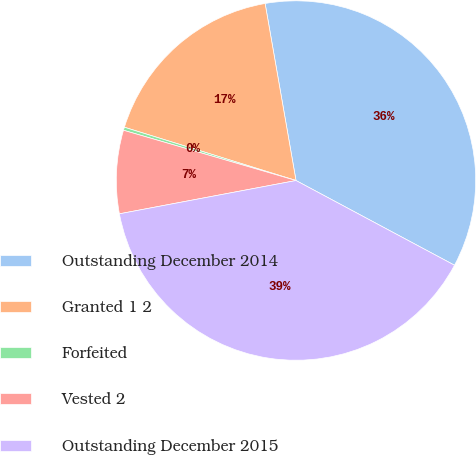Convert chart to OTSL. <chart><loc_0><loc_0><loc_500><loc_500><pie_chart><fcel>Outstanding December 2014<fcel>Granted 1 2<fcel>Forfeited<fcel>Vested 2<fcel>Outstanding December 2015<nl><fcel>35.57%<fcel>17.46%<fcel>0.28%<fcel>7.48%<fcel>39.23%<nl></chart> 